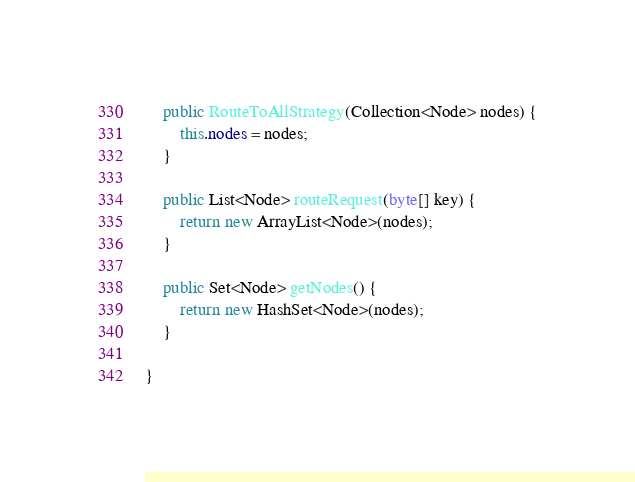<code> <loc_0><loc_0><loc_500><loc_500><_Java_>
    public RouteToAllStrategy(Collection<Node> nodes) {
        this.nodes = nodes;
    }

    public List<Node> routeRequest(byte[] key) {
        return new ArrayList<Node>(nodes);
    }

    public Set<Node> getNodes() {
        return new HashSet<Node>(nodes);
    }

}
</code> 